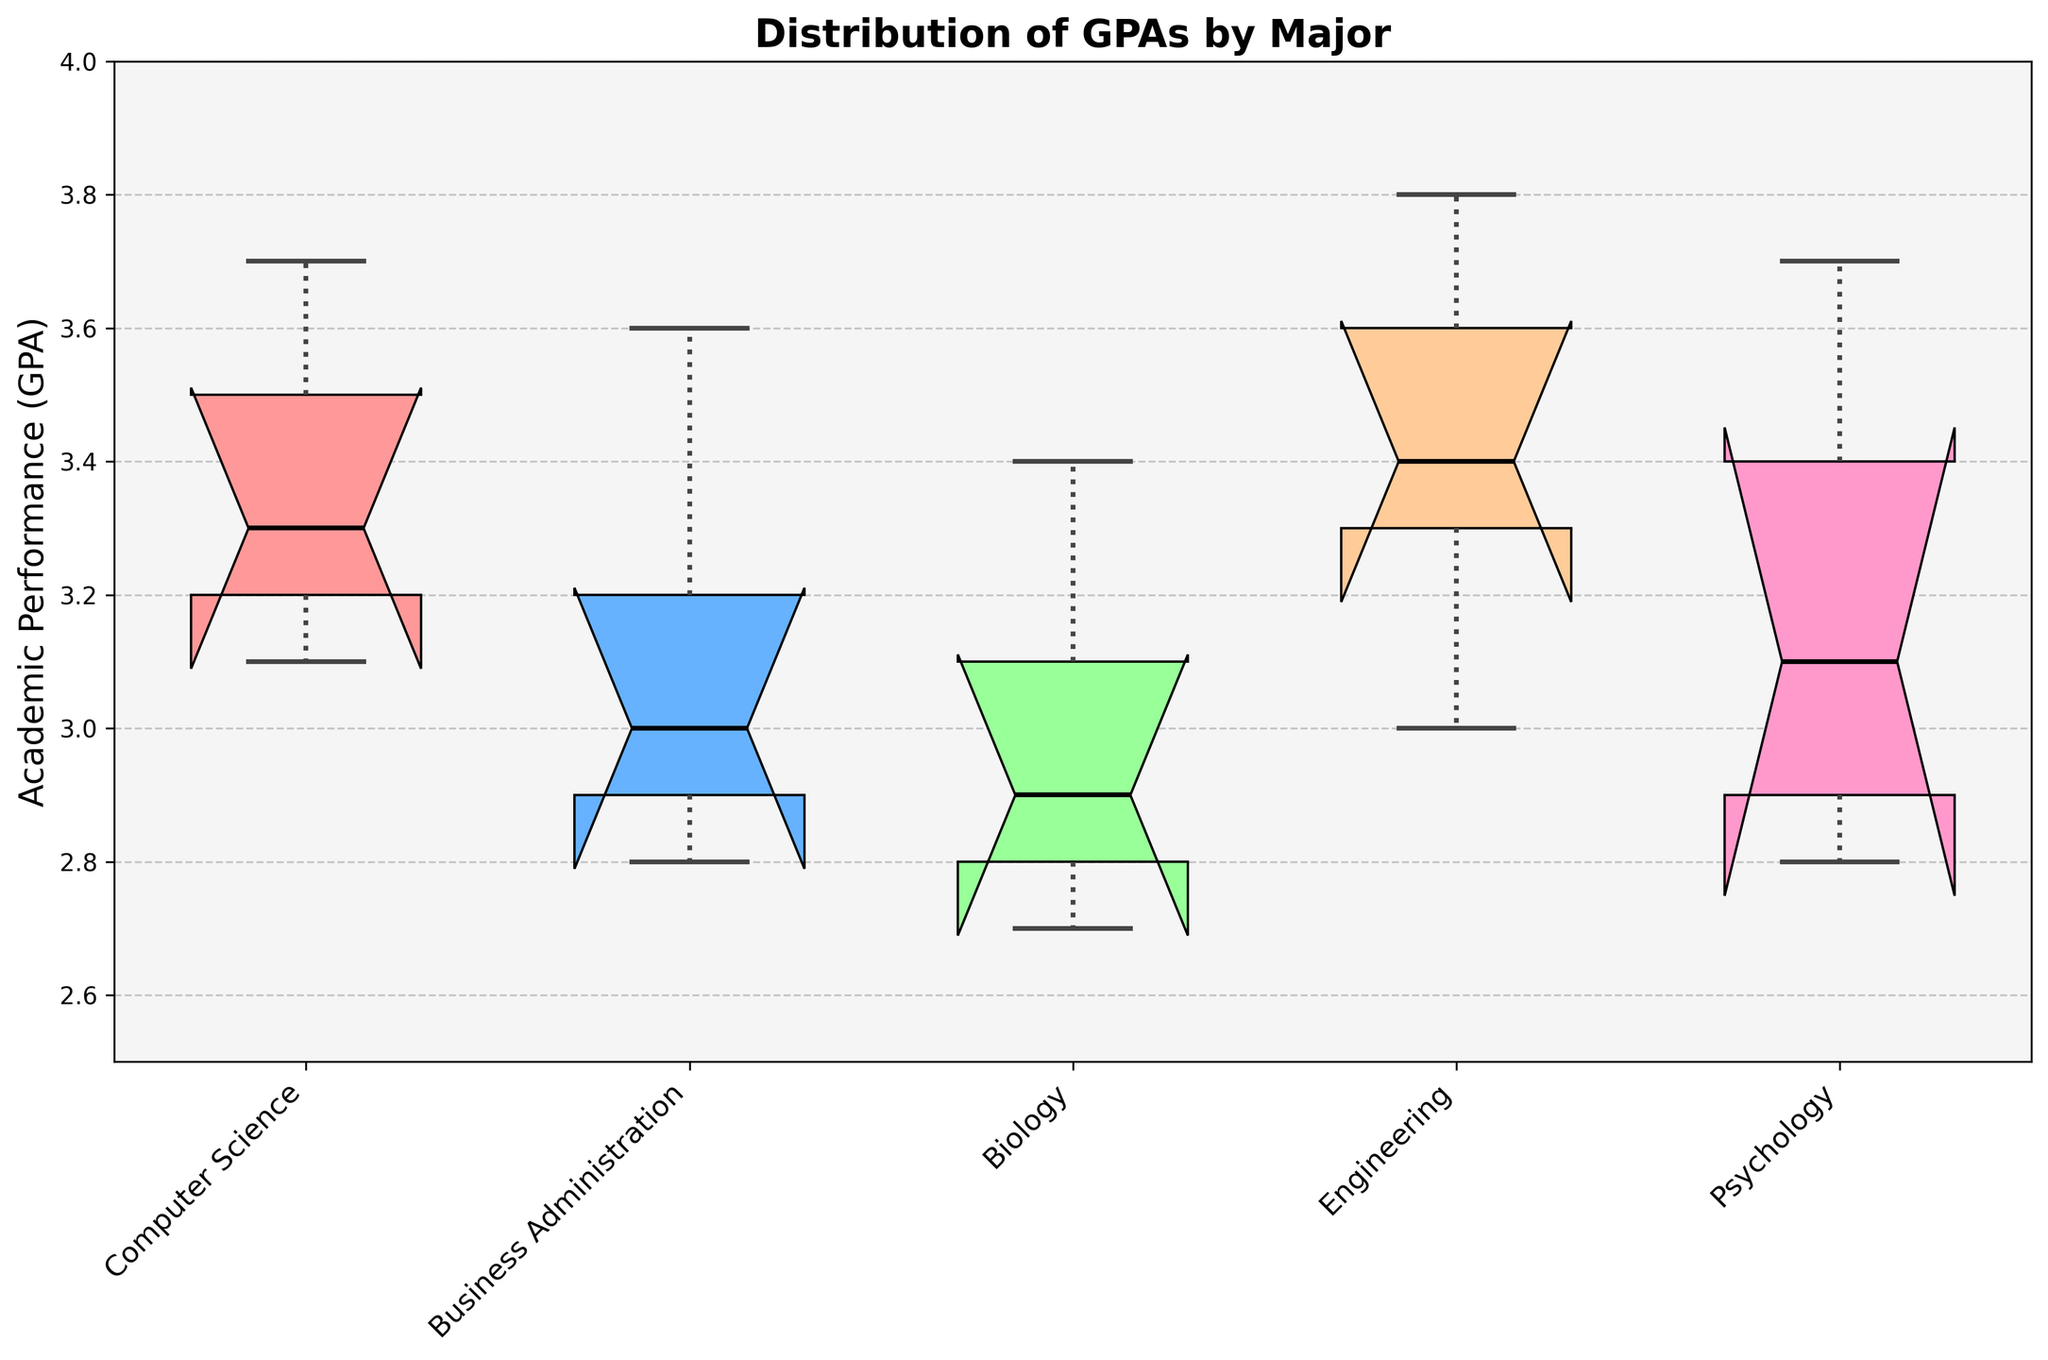What is the title of the figure? The title of the figure is usually displayed at the top. It gives an overview of what the figure represents. By looking at the top, you can see the title "Distribution of GPAs by Major".
Answer: Distribution of GPAs by Major Which major has the highest median GPA? Medians in box plots are usually indicated by a line within the box. By locating the highest line among the five majors, you see that Engineering has the highest median GPA.
Answer: Engineering What is the lower quartile (Q1) of GPA for Psychology students? The lower quartile or Q1 in a box plot is the bottom of the box. For Psychology, identify the bottom line of the box, which represents Q1.
Answer: 2.9 (approx) Which major has the lowest median GPA? The median in a box plot is indicated by a line within the box. By finding the lowest line among the five majors, you see that Biology has the lowest median GPA.
Answer: Biology Are there any outliers in the GPA data for Business Administration students? Outliers in a box plot are represented by points outside the whiskers. For Business Administration, check if there are any points that fall outside the whiskers.
Answer: No Compare the spread of GPAs for Computer Science and Biology. Which one has a wider spread? The spread can be assessed by the length of the box and whiskers in a box plot. For Computer Science and Biology, compare the lengths to determine which is wider.
Answer: Computer Science What is the median GPA for Business Administration students? The median is represented by the line within the box plot for Business Administration. Identify this middle line to find the value.
Answer: 3.0 (approx) Which major has the narrowest spread of GPA? The spread in a box plot is indicated by the combined length of the box and whiskers. The major with the shortest combined length has the narrowest spread.
Answer: Psychology How does the GPA distribution for Engineering compare to Biology? To compare GPA distributions, look at the location of the medians, quartile ranges, and whiskers in box plots for both majors. Note the differences in values and spread.
Answer: Engineering has a higher median and a broader spread compared to Biology 